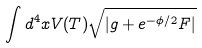Convert formula to latex. <formula><loc_0><loc_0><loc_500><loc_500>\int d ^ { 4 } x V ( T ) \sqrt { | g + e ^ { - \phi / 2 } F | }</formula> 